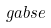<formula> <loc_0><loc_0><loc_500><loc_500>\ g a b s e</formula> 